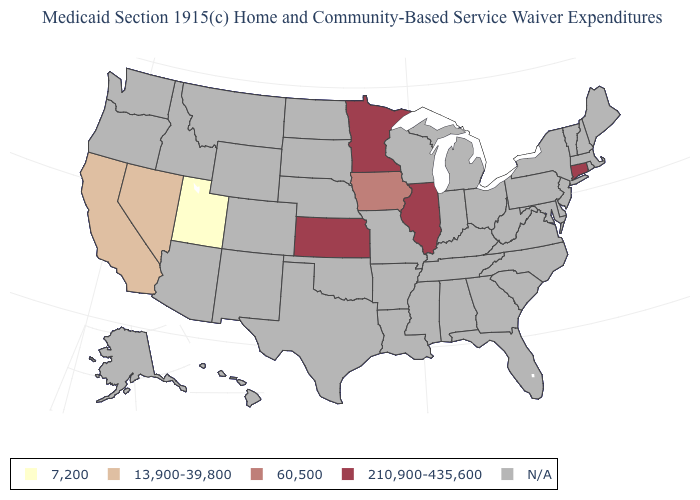Does California have the highest value in the West?
Answer briefly. Yes. What is the value of Maine?
Write a very short answer. N/A. Which states have the lowest value in the USA?
Answer briefly. Utah. What is the lowest value in the Northeast?
Short answer required. 210,900-435,600. Name the states that have a value in the range N/A?
Give a very brief answer. Alabama, Alaska, Arizona, Arkansas, Colorado, Delaware, Florida, Georgia, Hawaii, Idaho, Indiana, Kentucky, Louisiana, Maine, Maryland, Massachusetts, Michigan, Mississippi, Missouri, Montana, Nebraska, New Hampshire, New Jersey, New Mexico, New York, North Carolina, North Dakota, Ohio, Oklahoma, Oregon, Pennsylvania, Rhode Island, South Carolina, South Dakota, Tennessee, Texas, Vermont, Virginia, Washington, West Virginia, Wisconsin, Wyoming. Which states have the lowest value in the USA?
Write a very short answer. Utah. Does Iowa have the highest value in the USA?
Keep it brief. No. Is the legend a continuous bar?
Give a very brief answer. No. What is the value of Montana?
Keep it brief. N/A. Does Nevada have the lowest value in the West?
Keep it brief. No. Is the legend a continuous bar?
Quick response, please. No. What is the value of Arizona?
Quick response, please. N/A. Name the states that have a value in the range 210,900-435,600?
Write a very short answer. Connecticut, Illinois, Kansas, Minnesota. 